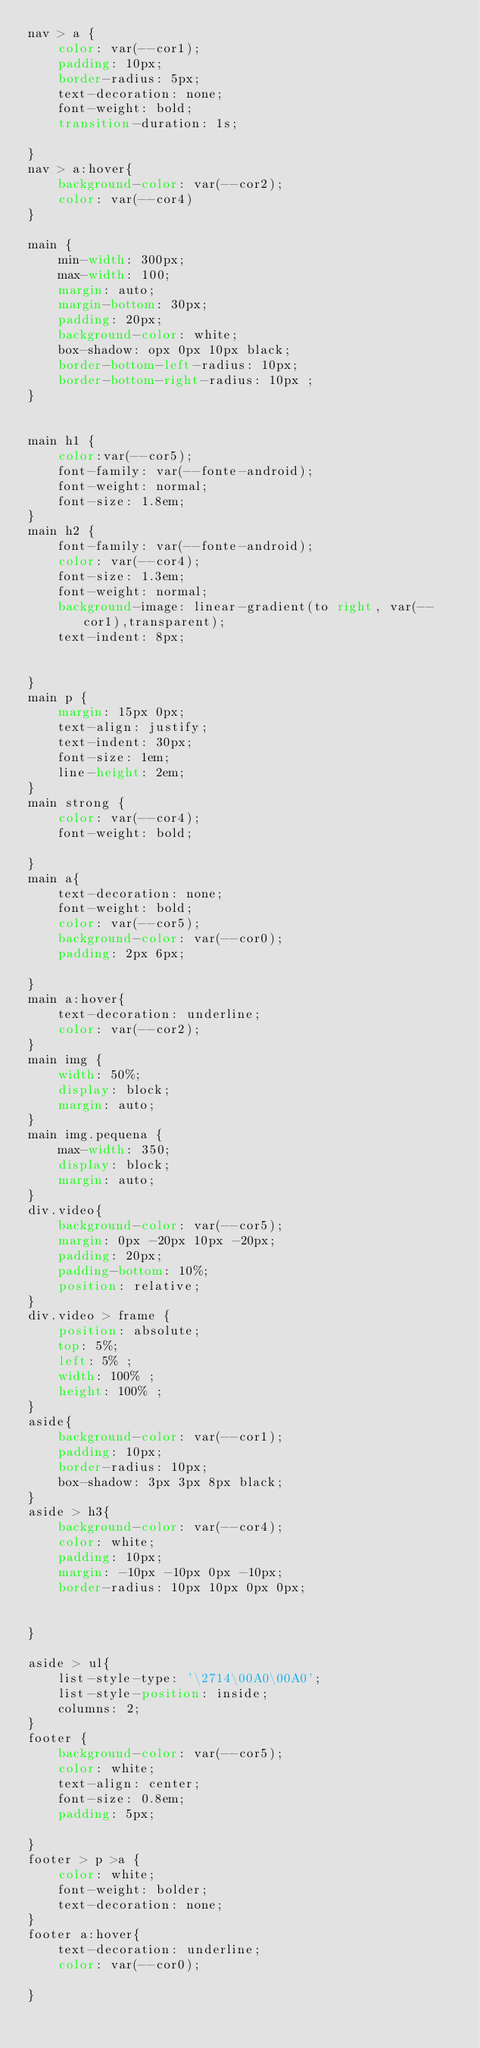Convert code to text. <code><loc_0><loc_0><loc_500><loc_500><_CSS_>nav > a {
    color: var(--cor1);
    padding: 10px;
    border-radius: 5px;
    text-decoration: none;
    font-weight: bold;
    transition-duration: 1s;

}
nav > a:hover{
    background-color: var(--cor2);
    color: var(--cor4)
}

main {
    min-width: 300px;
    max-width: 100;
    margin: auto;
    margin-bottom: 30px;
    padding: 20px;
    background-color: white;
    box-shadow: opx 0px 10px black;
    border-bottom-left-radius: 10px;
    border-bottom-right-radius: 10px ;
}


main h1 {
    color:var(--cor5);
    font-family: var(--fonte-android);
    font-weight: normal;
    font-size: 1.8em;
}
main h2 {
    font-family: var(--fonte-android);
    color: var(--cor4);
    font-size: 1.3em;
    font-weight: normal;
    background-image: linear-gradient(to right, var(--cor1),transparent);
    text-indent: 8px;


}
main p {
    margin: 15px 0px;
    text-align: justify;
    text-indent: 30px;
    font-size: 1em;
    line-height: 2em;
}
main strong {
    color: var(--cor4);
    font-weight: bold;
    
}
main a{
    text-decoration: none;
    font-weight: bold;
    color: var(--cor5);
    background-color: var(--cor0);
    padding: 2px 6px;

}
main a:hover{
    text-decoration: underline;
    color: var(--cor2);
}
main img {
    width: 50%;
    display: block;
    margin: auto;
}
main img.pequena {
    max-width: 350; 
    display: block;
    margin: auto;
}
div.video{
    background-color: var(--cor5);
    margin: 0px -20px 10px -20px;
    padding: 20px;
    padding-bottom: 10%;
    position: relative;
}
div.video > frame {
    position: absolute;
    top: 5%;
    left: 5% ;
    width: 100% ;
    height: 100% ;
}
aside{
    background-color: var(--cor1);
    padding: 10px;
    border-radius: 10px;
    box-shadow: 3px 3px 8px black;
}
aside > h3{
    background-color: var(--cor4);
    color: white;
    padding: 10px;
    margin: -10px -10px 0px -10px;
    border-radius: 10px 10px 0px 0px;


}

aside > ul{
    list-style-type: '\2714\00A0\00A0';
    list-style-position: inside;
    columns: 2;
}
footer {
    background-color: var(--cor5);
    color: white;
    text-align: center;
    font-size: 0.8em;
    padding: 5px;

}
footer > p >a {
    color: white;
    font-weight: bolder;
    text-decoration: none;
}
footer a:hover{
    text-decoration: underline;
    color: var(--cor0);

}



</code> 